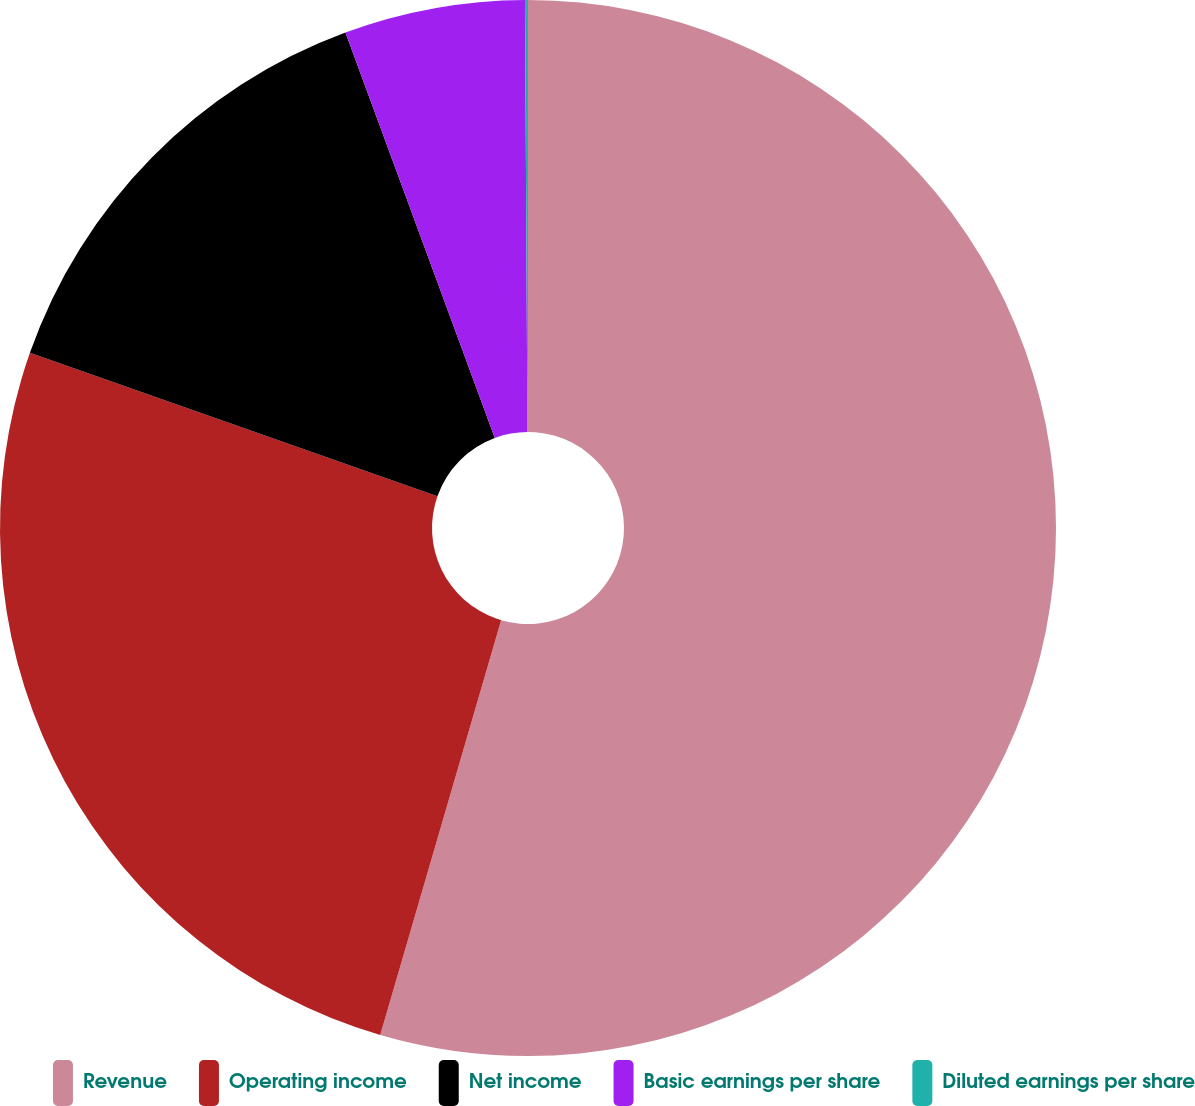Convert chart. <chart><loc_0><loc_0><loc_500><loc_500><pie_chart><fcel>Revenue<fcel>Operating income<fcel>Net income<fcel>Basic earnings per share<fcel>Diluted earnings per share<nl><fcel>54.52%<fcel>25.87%<fcel>14.0%<fcel>5.53%<fcel>0.09%<nl></chart> 